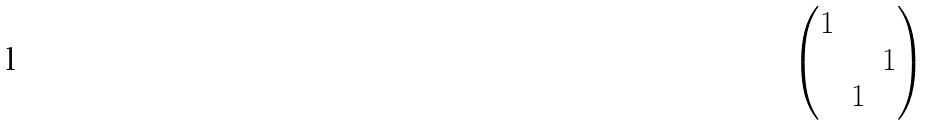Convert formula to latex. <formula><loc_0><loc_0><loc_500><loc_500>\begin{pmatrix} 1 & & \\ & & 1 \\ & 1 & \end{pmatrix}</formula> 